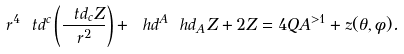Convert formula to latex. <formula><loc_0><loc_0><loc_500><loc_500>r ^ { 4 } \ t d ^ { c } \left ( \frac { \ t d _ { c } Z } { r ^ { 2 } } \right ) + \ h d ^ { A } \ h d _ { A } Z + 2 Z = 4 Q A ^ { > 1 } + z ( \theta , \phi ) .</formula> 